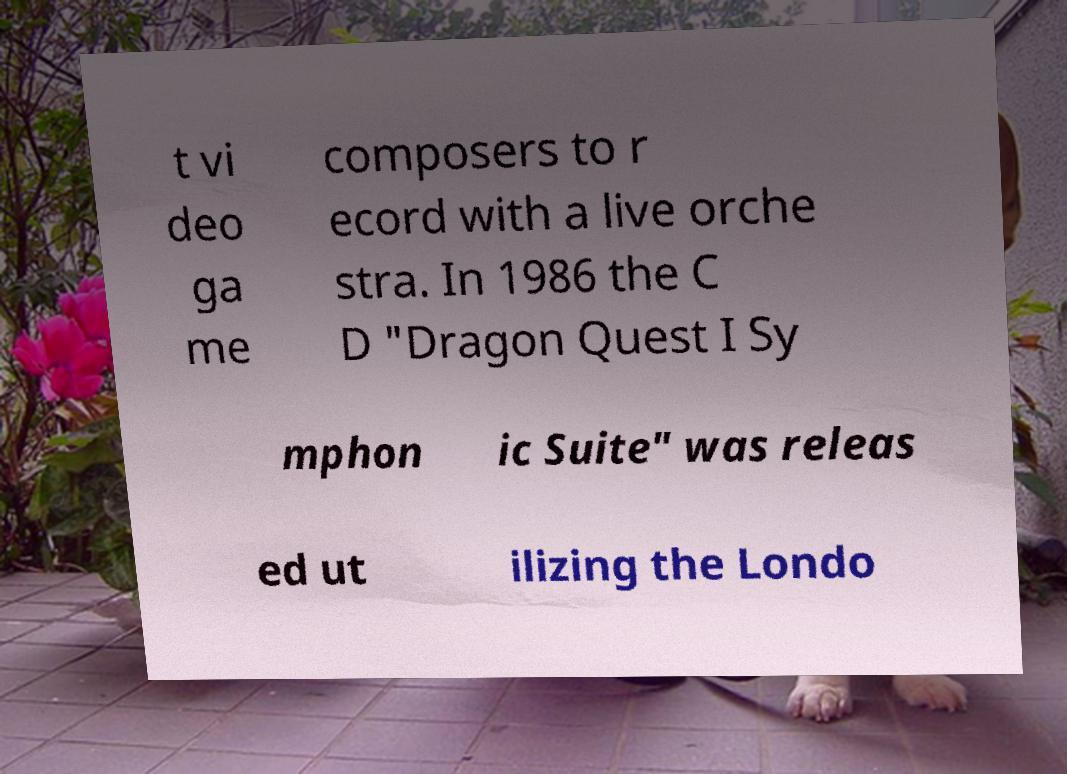Please identify and transcribe the text found in this image. t vi deo ga me composers to r ecord with a live orche stra. In 1986 the C D "Dragon Quest I Sy mphon ic Suite" was releas ed ut ilizing the Londo 